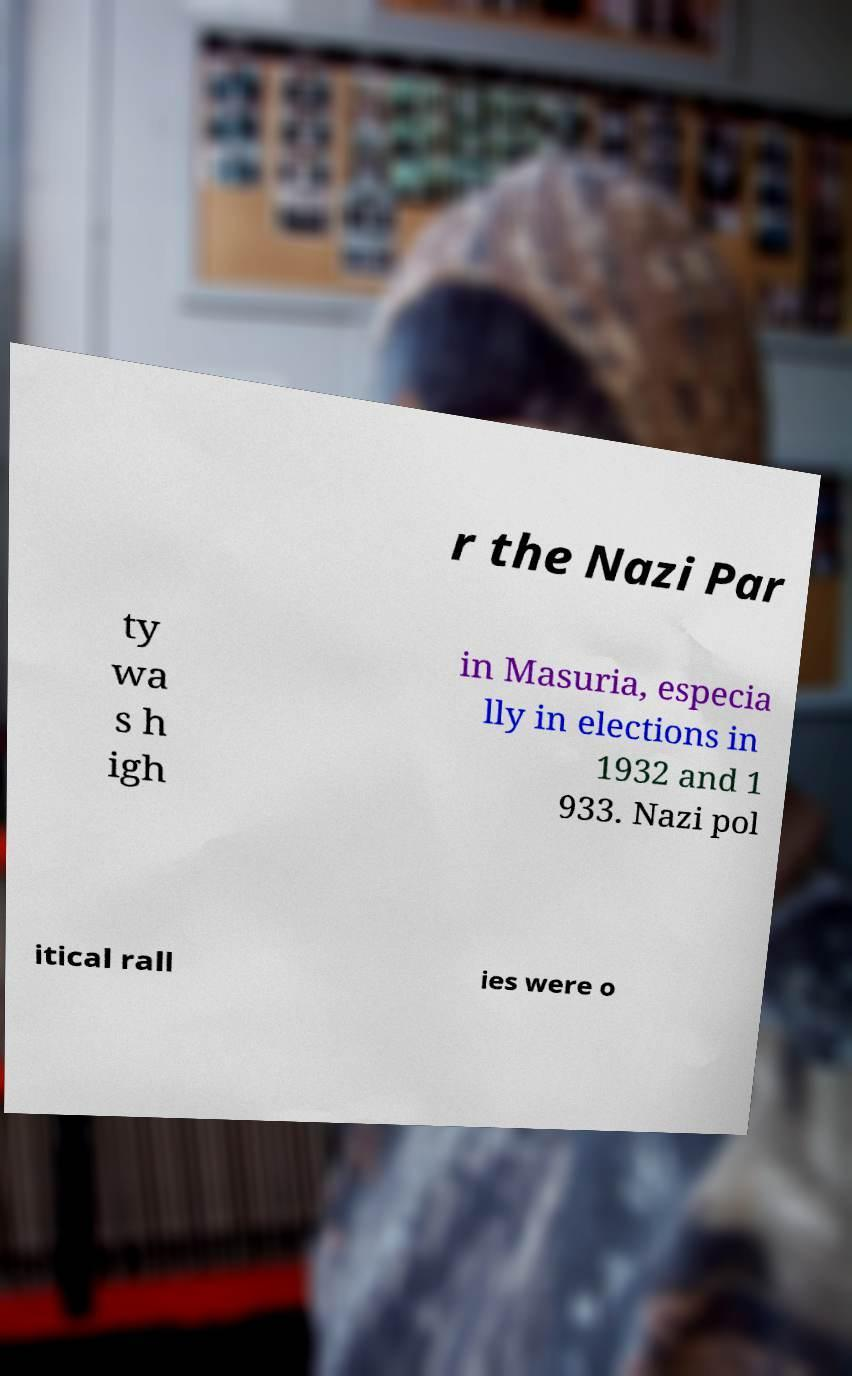Please identify and transcribe the text found in this image. r the Nazi Par ty wa s h igh in Masuria, especia lly in elections in 1932 and 1 933. Nazi pol itical rall ies were o 